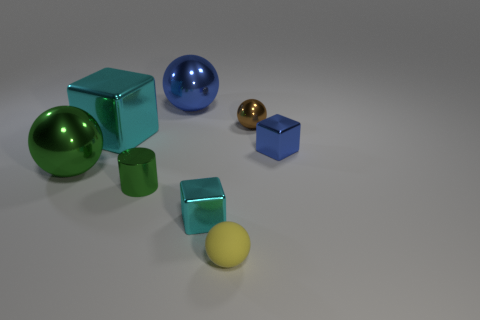Add 1 big green metal spheres. How many objects exist? 9 Subtract all blocks. How many objects are left? 5 Add 4 blue blocks. How many blue blocks exist? 5 Subtract 0 yellow cylinders. How many objects are left? 8 Subtract all cyan metallic objects. Subtract all small metal things. How many objects are left? 2 Add 6 yellow rubber balls. How many yellow rubber balls are left? 7 